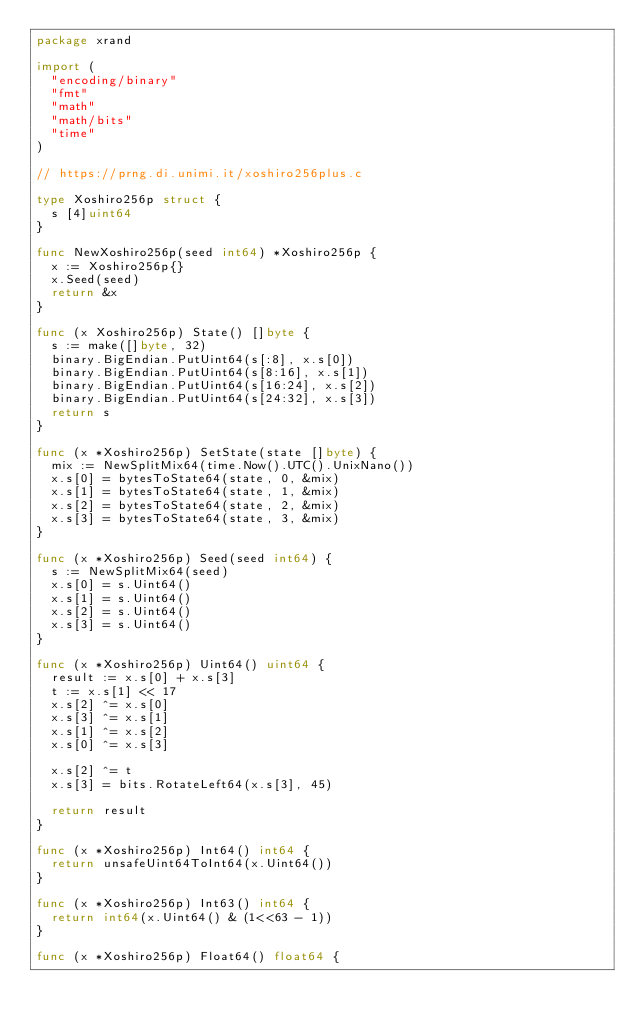Convert code to text. <code><loc_0><loc_0><loc_500><loc_500><_Go_>package xrand

import (
	"encoding/binary"
	"fmt"
	"math"
	"math/bits"
	"time"
)

// https://prng.di.unimi.it/xoshiro256plus.c

type Xoshiro256p struct {
	s [4]uint64
}

func NewXoshiro256p(seed int64) *Xoshiro256p {
	x := Xoshiro256p{}
	x.Seed(seed)
	return &x
}

func (x Xoshiro256p) State() []byte {
	s := make([]byte, 32)
	binary.BigEndian.PutUint64(s[:8], x.s[0])
	binary.BigEndian.PutUint64(s[8:16], x.s[1])
	binary.BigEndian.PutUint64(s[16:24], x.s[2])
	binary.BigEndian.PutUint64(s[24:32], x.s[3])
	return s
}

func (x *Xoshiro256p) SetState(state []byte) {
	mix := NewSplitMix64(time.Now().UTC().UnixNano())
	x.s[0] = bytesToState64(state, 0, &mix)
	x.s[1] = bytesToState64(state, 1, &mix)
	x.s[2] = bytesToState64(state, 2, &mix)
	x.s[3] = bytesToState64(state, 3, &mix)
}

func (x *Xoshiro256p) Seed(seed int64) {
	s := NewSplitMix64(seed)
	x.s[0] = s.Uint64()
	x.s[1] = s.Uint64()
	x.s[2] = s.Uint64()
	x.s[3] = s.Uint64()
}

func (x *Xoshiro256p) Uint64() uint64 {
	result := x.s[0] + x.s[3]
	t := x.s[1] << 17
	x.s[2] ^= x.s[0]
	x.s[3] ^= x.s[1]
	x.s[1] ^= x.s[2]
	x.s[0] ^= x.s[3]

	x.s[2] ^= t
	x.s[3] = bits.RotateLeft64(x.s[3], 45)

	return result
}

func (x *Xoshiro256p) Int64() int64 {
	return unsafeUint64ToInt64(x.Uint64())
}

func (x *Xoshiro256p) Int63() int64 {
	return int64(x.Uint64() & (1<<63 - 1))
}

func (x *Xoshiro256p) Float64() float64 {</code> 